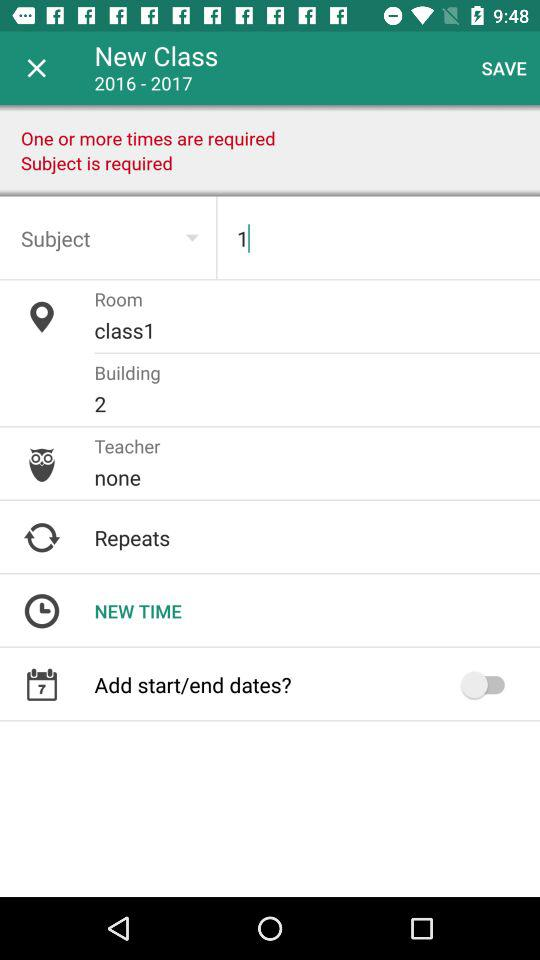What building number is mentioned? The mentioned building number is 2. 